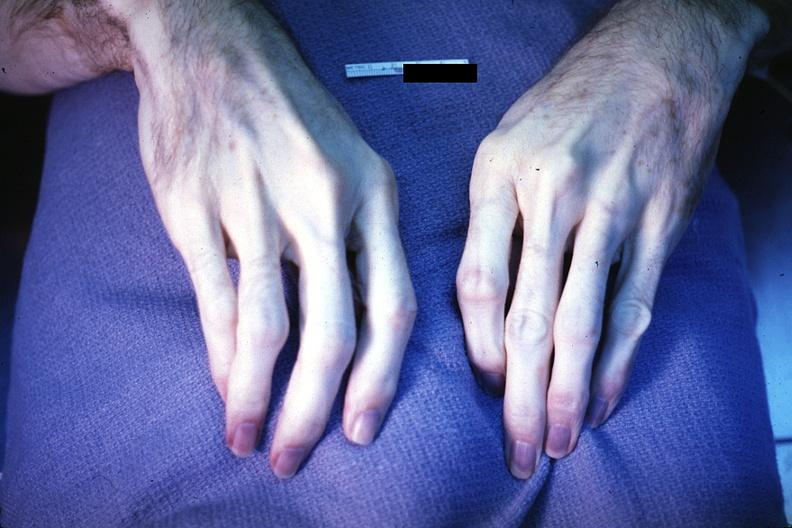what does this image show?
Answer the question using a single word or phrase. Excellent example of acrocyanosis 